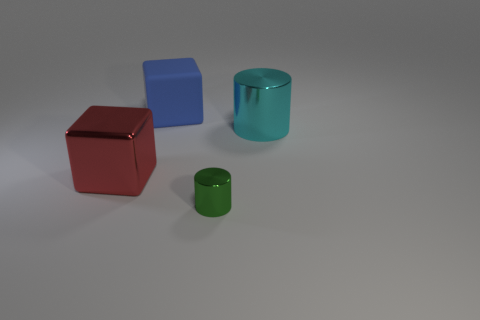What number of red objects are small metal blocks or blocks?
Give a very brief answer. 1. What number of small metallic objects have the same shape as the large red thing?
Give a very brief answer. 0. The cyan metal object that is the same size as the matte thing is what shape?
Provide a short and direct response. Cylinder. There is a big blue rubber object; are there any cylinders behind it?
Give a very brief answer. No. There is a metal thing that is on the left side of the matte block; is there a metallic thing that is behind it?
Your answer should be compact. Yes. Is the number of big red objects that are on the right side of the small thing less than the number of large metallic blocks that are to the left of the cyan cylinder?
Make the answer very short. Yes. Is there any other thing that is the same size as the green metal thing?
Keep it short and to the point. No. The blue matte thing is what shape?
Your answer should be very brief. Cube. There is a block right of the red block; what is it made of?
Make the answer very short. Rubber. What size is the green shiny object on the right side of the large thing behind the big shiny object that is on the right side of the blue block?
Offer a terse response. Small. 